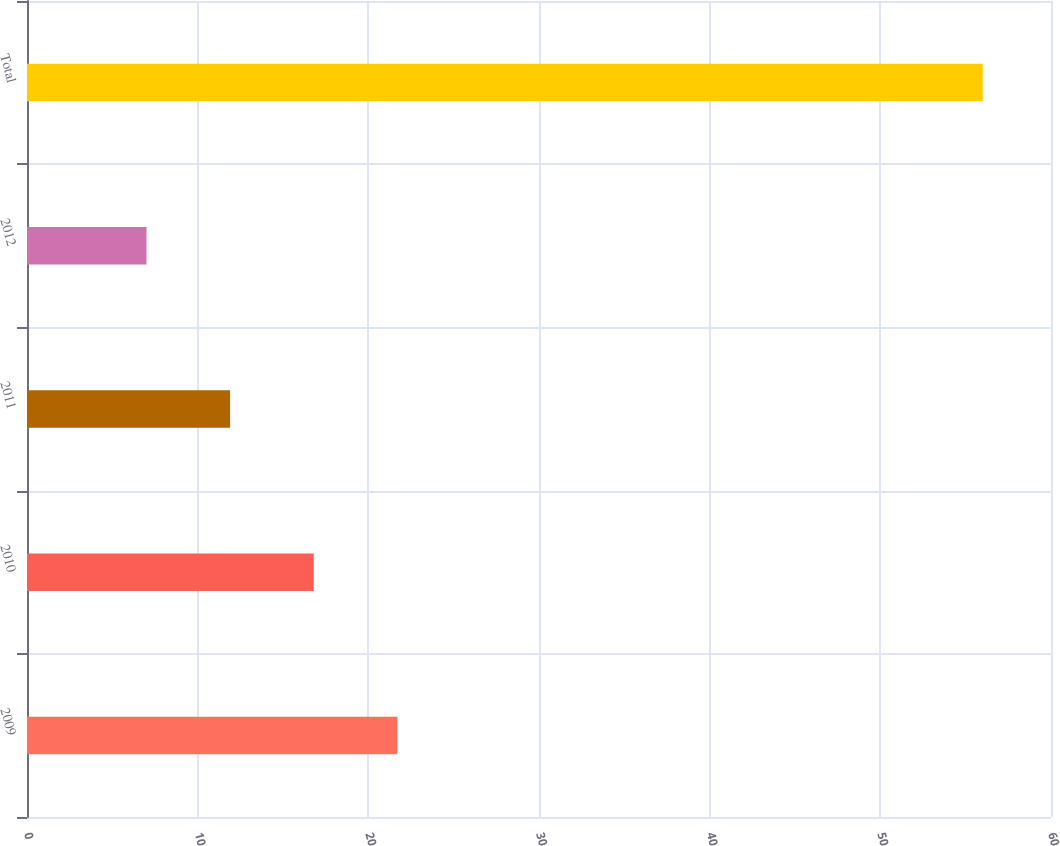Convert chart to OTSL. <chart><loc_0><loc_0><loc_500><loc_500><bar_chart><fcel>2009<fcel>2010<fcel>2011<fcel>2012<fcel>Total<nl><fcel>21.7<fcel>16.8<fcel>11.9<fcel>7<fcel>56<nl></chart> 